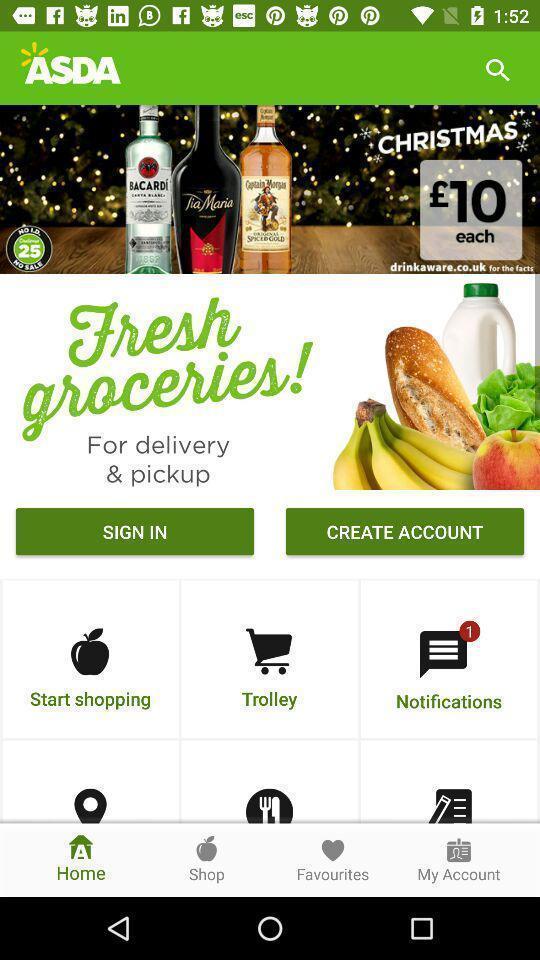Explain the elements present in this screenshot. Sign in page of a groceries app. 